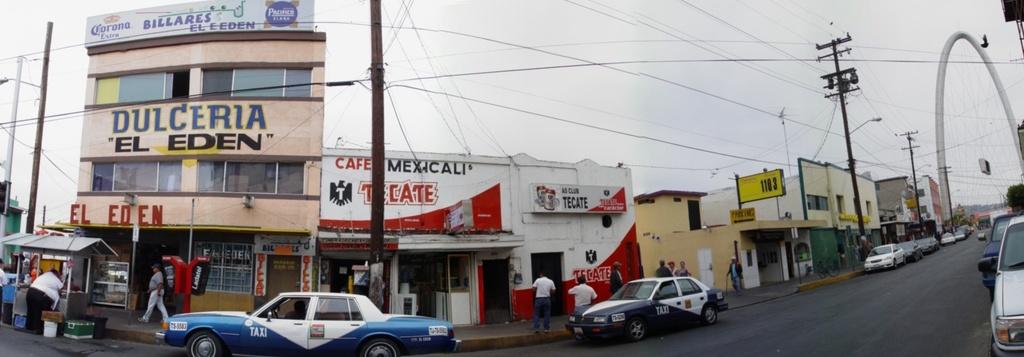What is in quotation marks?
Provide a short and direct response. El eden. What's written in red?
Provide a short and direct response. El eden. 